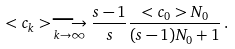Convert formula to latex. <formula><loc_0><loc_0><loc_500><loc_500>< c _ { k } > \underset { k \rightarrow \infty } { \longrightarrow } \frac { s - 1 } { s } \frac { < c _ { 0 } > N _ { 0 } } { ( s - 1 ) N _ { 0 } + 1 } \, .</formula> 